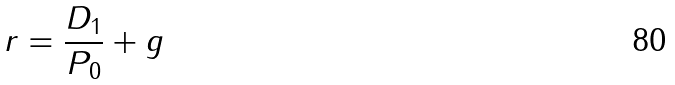Convert formula to latex. <formula><loc_0><loc_0><loc_500><loc_500>r = \frac { D _ { 1 } } { P _ { 0 } } + g</formula> 